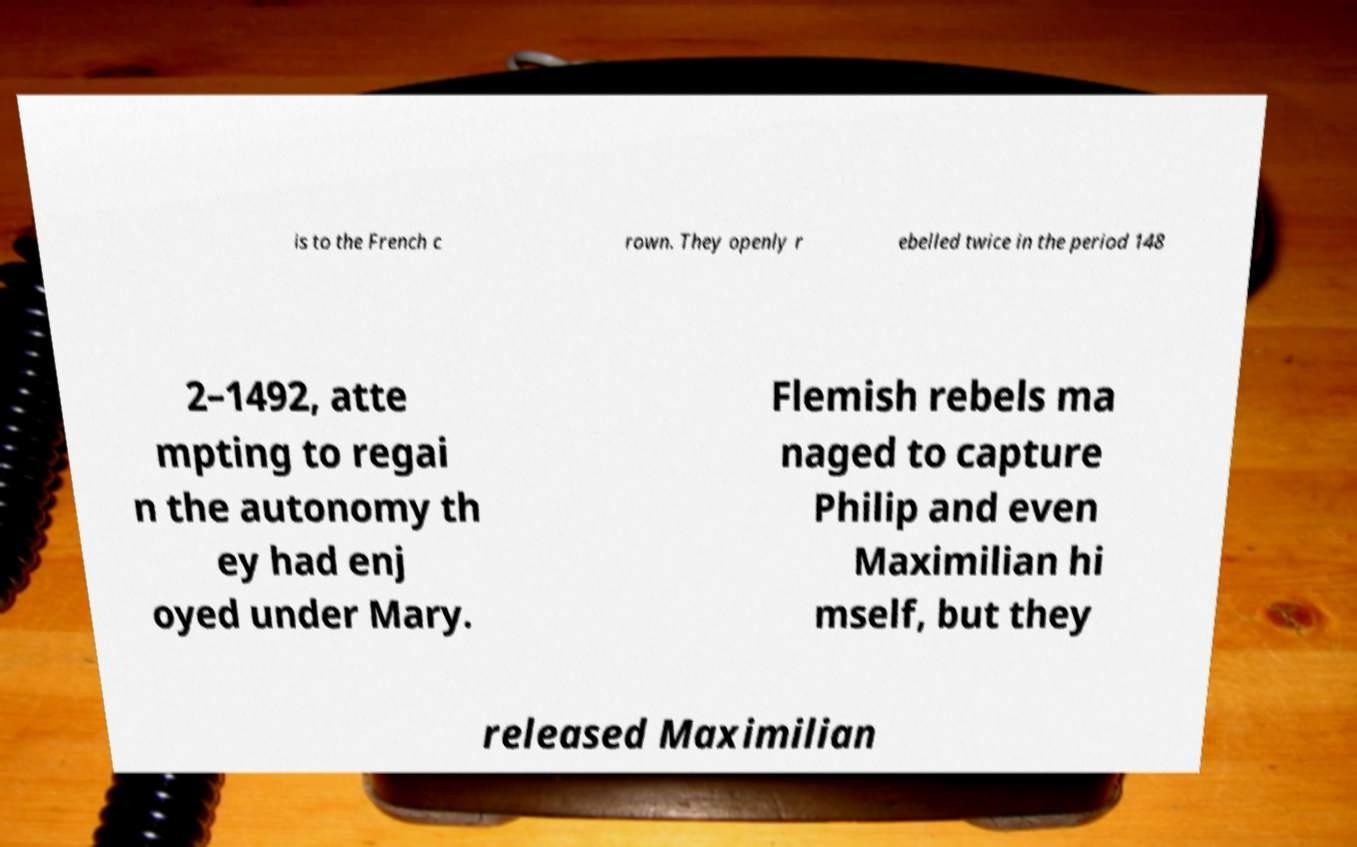Could you assist in decoding the text presented in this image and type it out clearly? is to the French c rown. They openly r ebelled twice in the period 148 2–1492, atte mpting to regai n the autonomy th ey had enj oyed under Mary. Flemish rebels ma naged to capture Philip and even Maximilian hi mself, but they released Maximilian 